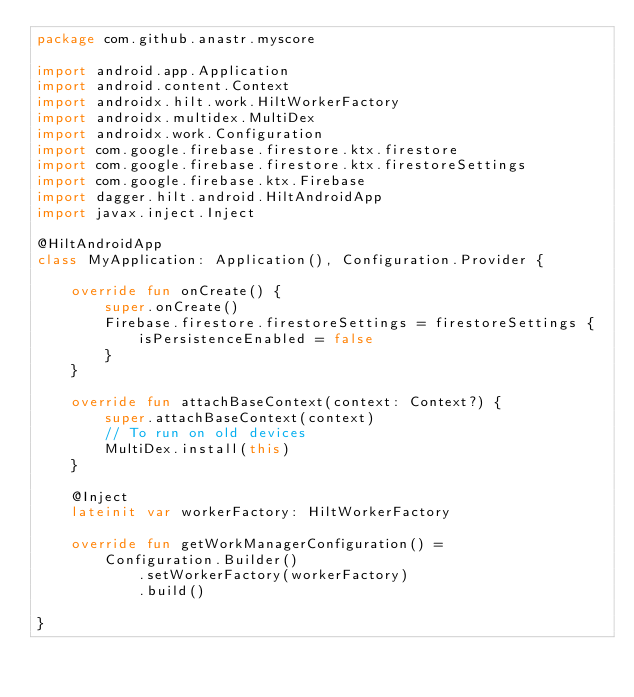Convert code to text. <code><loc_0><loc_0><loc_500><loc_500><_Kotlin_>package com.github.anastr.myscore

import android.app.Application
import android.content.Context
import androidx.hilt.work.HiltWorkerFactory
import androidx.multidex.MultiDex
import androidx.work.Configuration
import com.google.firebase.firestore.ktx.firestore
import com.google.firebase.firestore.ktx.firestoreSettings
import com.google.firebase.ktx.Firebase
import dagger.hilt.android.HiltAndroidApp
import javax.inject.Inject

@HiltAndroidApp
class MyApplication: Application(), Configuration.Provider {

    override fun onCreate() {
        super.onCreate()
        Firebase.firestore.firestoreSettings = firestoreSettings {
            isPersistenceEnabled = false
        }
    }

    override fun attachBaseContext(context: Context?) {
        super.attachBaseContext(context)
        // To run on old devices
        MultiDex.install(this)
    }

    @Inject
    lateinit var workerFactory: HiltWorkerFactory

    override fun getWorkManagerConfiguration() =
        Configuration.Builder()
            .setWorkerFactory(workerFactory)
            .build()

}
</code> 